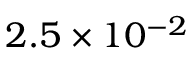Convert formula to latex. <formula><loc_0><loc_0><loc_500><loc_500>2 . 5 \times 1 0 ^ { - 2 }</formula> 